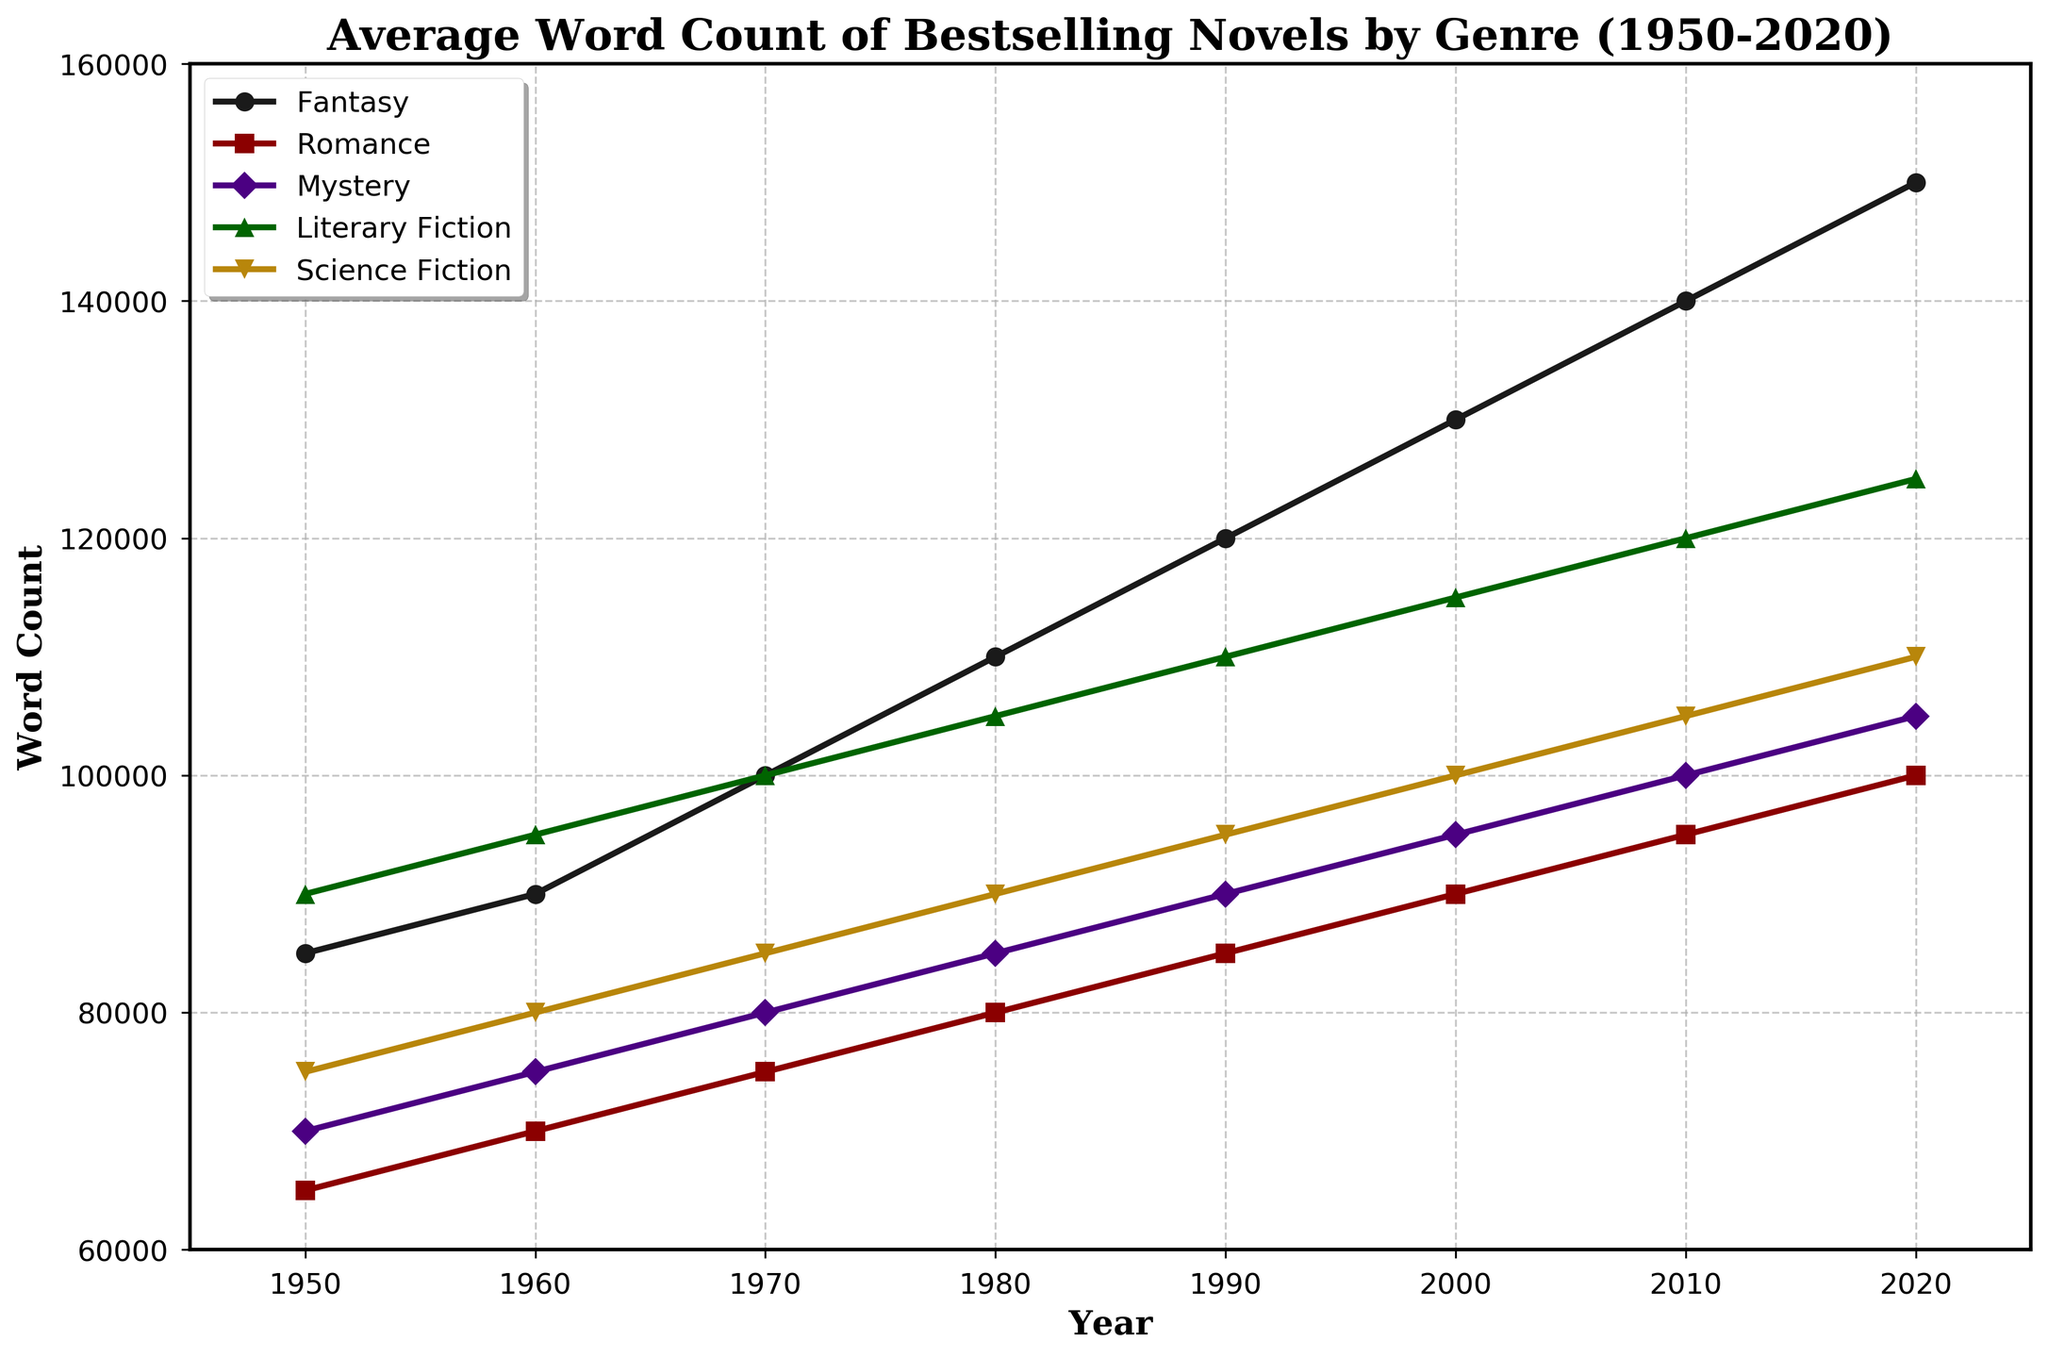What genre had the highest average word count in 1950? Looking at the plot for the year 1950, the highest point corresponds to the 'Literary Fiction' line.
Answer: Literary Fiction Which genre showed the greatest increase in average word count from 1950 to 2020? Calculate the increase for each genre by subtracting the 1950 value from the 2020 value. 'Fantasy' shows the greatest increase from 85000 to 150000, an increase of 65000 words.
Answer: Fantasy Between which decades did the 'Science Fiction' genre show the largest increase in average word count? Find the largest gap between two consecutive decades for 'Science Fiction'. The largest jump is from 2010 to 2020, increasing from 105,000 to 110,000, a difference of 5,000 words.
Answer: 2010 to 2020 Which genre had the smallest increase in average word count from 1950 to 2020? Calculate the increase for each genre by subtracting the 1950 value from the 2020 value. 'Romance' shows the smallest increase of 35,000 words.
Answer: Romance What is the trend of the 'Mystery' genre's average word count from 1950 to 2020? Observing the 'Mystery' line, it shows a steady increase from 70,000 in 1950 to 105,000 in 2020.
Answer: Increasing How many genres have surpassed an average word count of 120,000 by 2020? Check the plot at the year 2020. 'Fantasy' and 'Literary Fiction' have surpassed 120,000.
Answer: 2 Which year shows a concurrence where all the genres' average word counts are increasing? Look for a year where all lines are upward sloping compared to the previous year. In 1980, all genres' lines show an increase compared to 1970.
Answer: 1980 In which year did the 'Romance' genre first reach an average word count of 100,000? Find the point on the 'Romance' line that first reaches 100,000. This happens in 2020.
Answer: 2020 Between 1950 and 2020, in which decade did the 'Fantasy' genre see the steepest increase in average word count? Examine the slope of the 'Fantasy' line across decades; the steepest increase is observed from 2000 to 2010.
Answer: 2000 to 2010 